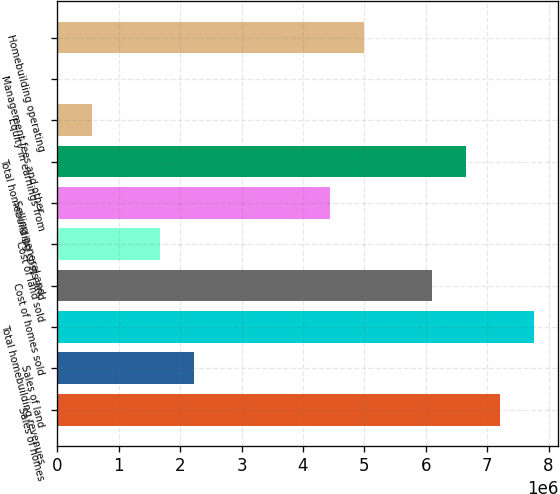Convert chart. <chart><loc_0><loc_0><loc_500><loc_500><bar_chart><fcel>Sales of homes<fcel>Sales of land<fcel>Total homebuilding revenues<fcel>Cost of homes sold<fcel>Cost of land sold<fcel>Selling general and<fcel>Total homebuilding costs and<fcel>Equity in earnings from<fcel>Management fees and other<fcel>Homebuilding operating<nl><fcel>7.21565e+06<fcel>2.23294e+06<fcel>7.76929e+06<fcel>6.10838e+06<fcel>1.6793e+06<fcel>4.44748e+06<fcel>6.66202e+06<fcel>572031<fcel>18396<fcel>5.00111e+06<nl></chart> 